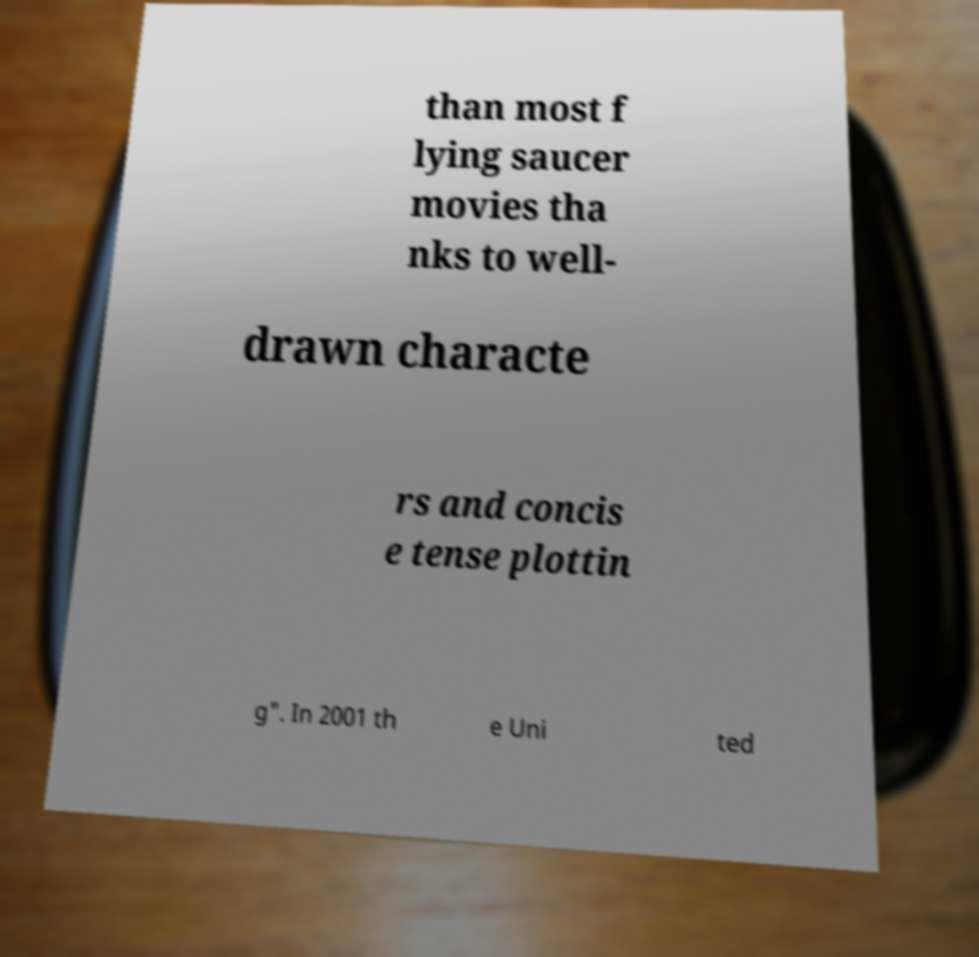Please read and relay the text visible in this image. What does it say? than most f lying saucer movies tha nks to well- drawn characte rs and concis e tense plottin g". In 2001 th e Uni ted 